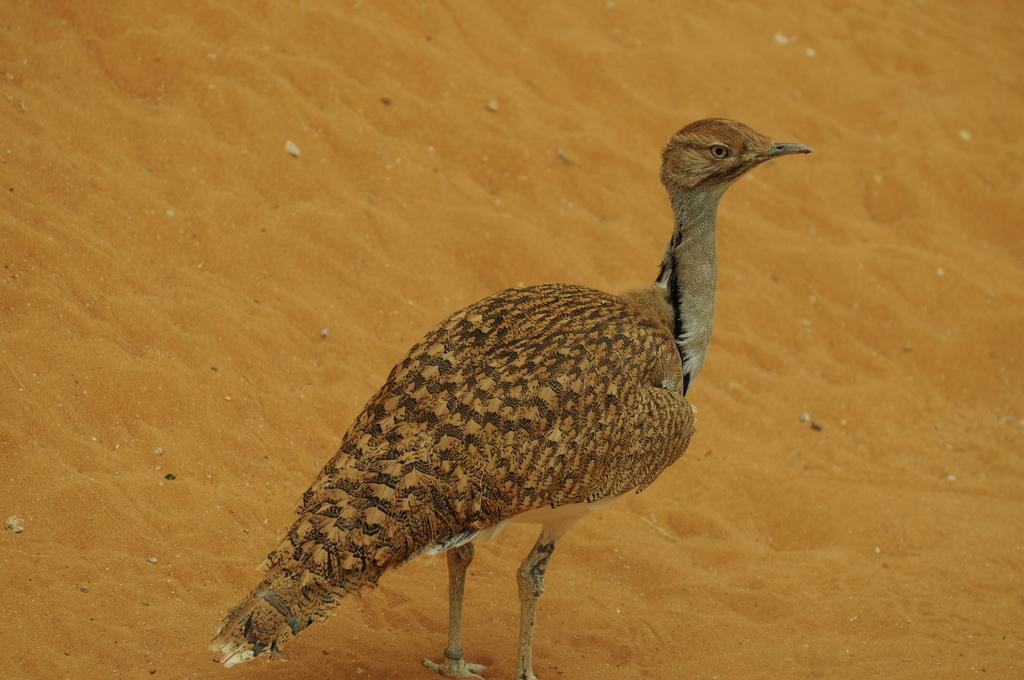What type of animal is in the image? There is a bird in the image. What body parts does the bird have? The bird has legs, feathers, eyes, and a beak. What is the texture of the ground in the image? There is sand in the image. What territory does the woman claim in the image? There is no woman or territory present in the image; it features a bird and sand. 